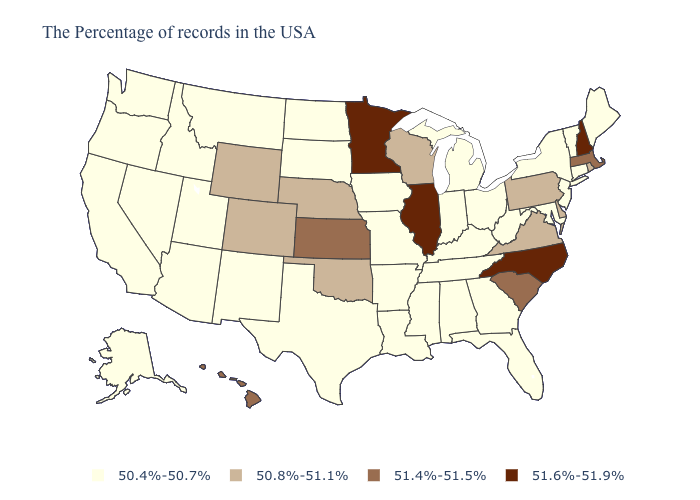Name the states that have a value in the range 51.6%-51.9%?
Write a very short answer. New Hampshire, North Carolina, Illinois, Minnesota. What is the value of Missouri?
Be succinct. 50.4%-50.7%. Which states hav the highest value in the South?
Answer briefly. North Carolina. What is the value of California?
Be succinct. 50.4%-50.7%. Name the states that have a value in the range 50.8%-51.1%?
Answer briefly. Rhode Island, Delaware, Pennsylvania, Virginia, Wisconsin, Nebraska, Oklahoma, Wyoming, Colorado. What is the value of Maryland?
Keep it brief. 50.4%-50.7%. Among the states that border Ohio , which have the lowest value?
Answer briefly. West Virginia, Michigan, Kentucky, Indiana. Which states hav the highest value in the West?
Quick response, please. Hawaii. What is the value of Kansas?
Give a very brief answer. 51.4%-51.5%. What is the value of Minnesota?
Write a very short answer. 51.6%-51.9%. What is the value of Ohio?
Write a very short answer. 50.4%-50.7%. Name the states that have a value in the range 51.6%-51.9%?
Concise answer only. New Hampshire, North Carolina, Illinois, Minnesota. What is the value of New Mexico?
Give a very brief answer. 50.4%-50.7%. Name the states that have a value in the range 51.4%-51.5%?
Short answer required. Massachusetts, South Carolina, Kansas, Hawaii. What is the value of Mississippi?
Answer briefly. 50.4%-50.7%. 